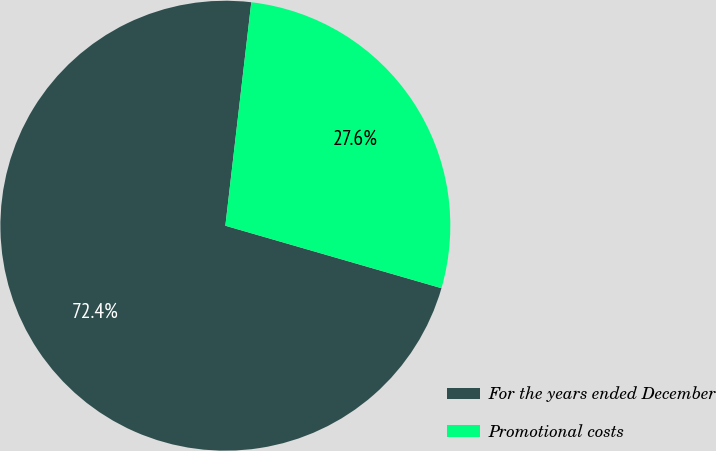<chart> <loc_0><loc_0><loc_500><loc_500><pie_chart><fcel>For the years ended December<fcel>Promotional costs<nl><fcel>72.36%<fcel>27.64%<nl></chart> 